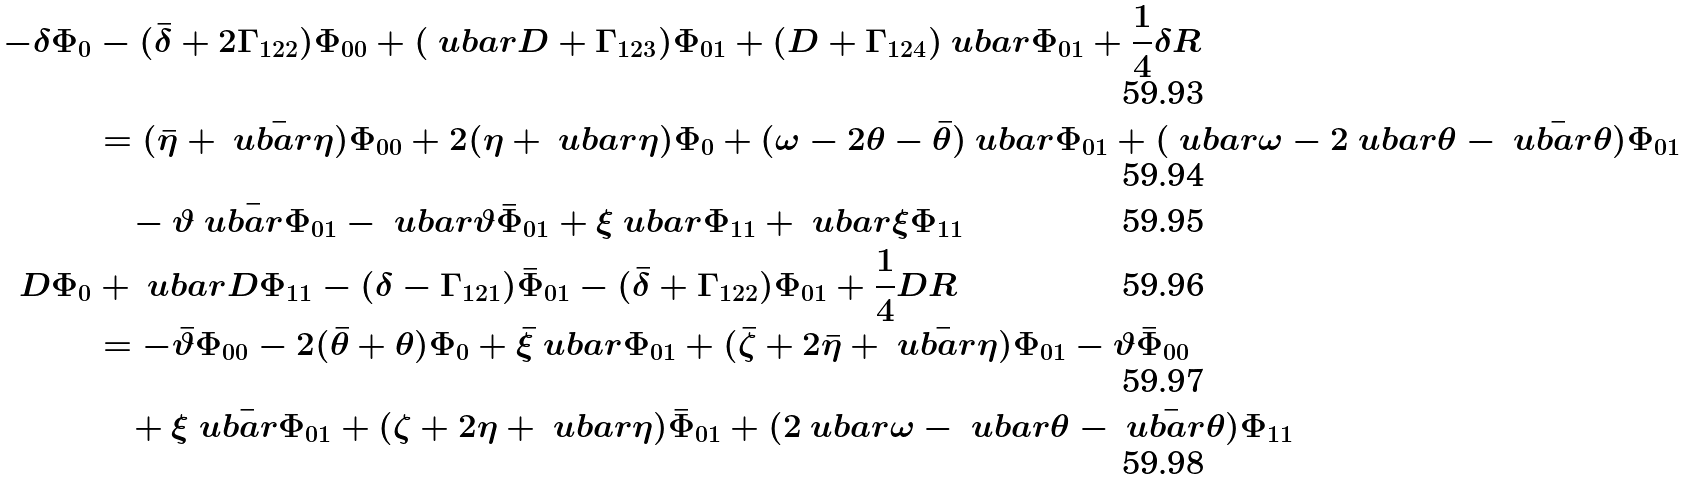Convert formula to latex. <formula><loc_0><loc_0><loc_500><loc_500>- \delta \Phi _ { 0 } & - ( \bar { \delta } + 2 \Gamma _ { 1 2 2 } ) \Phi _ { 0 0 } + ( \ u b a r { D } + \Gamma _ { 1 2 3 } ) \Phi _ { 0 1 } + ( D + \Gamma _ { 1 2 4 } ) \ u b a r \Phi _ { 0 1 } + \frac { 1 } { 4 } \delta R \\ & = ( \bar { \eta } + \bar { \ u b a r \eta } ) \Phi _ { 0 0 } + 2 ( \eta + \ u b a r { \eta } ) \Phi _ { 0 } + ( \omega - 2 \theta - \bar { \theta } ) \ u b a r \Phi _ { 0 1 } + ( \ u b a r \omega - 2 \ u b a r \theta - \bar { \ u b a r \theta } ) \Phi _ { 0 1 } \\ & \quad - \vartheta \bar { \ u b a r \Phi } _ { 0 1 } - \ u b a r \vartheta \bar { \Phi } _ { 0 1 } + \xi \ u b a r \Phi _ { 1 1 } + \ u b a r \xi \Phi _ { 1 1 } \\ D \Phi _ { 0 } & + \ u b a r { D } \Phi _ { 1 1 } - ( \delta - \Gamma _ { 1 2 1 } ) \bar { \Phi } _ { 0 1 } - ( \bar { \delta } + \Gamma _ { 1 2 2 } ) \Phi _ { 0 1 } + \frac { 1 } { 4 } D R \\ & = - \bar { \vartheta } \Phi _ { 0 0 } - 2 ( \bar { \theta } + \theta ) \Phi _ { 0 } + \bar { \xi } \ u b a r \Phi _ { 0 1 } + ( \bar { \zeta } + 2 \bar { \eta } + \bar { \ u b a r \eta } ) \Phi _ { 0 1 } - \vartheta \bar { \Phi } _ { 0 0 } \\ & \quad + \xi \bar { \ u b a r \Phi } _ { 0 1 } + ( \zeta + 2 \eta + \ u b a r \eta ) \bar { \Phi } _ { 0 1 } + ( 2 \ u b a r \omega - \ u b a r \theta - \bar { \ u b a r \theta } ) \Phi _ { 1 1 }</formula> 